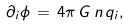Convert formula to latex. <formula><loc_0><loc_0><loc_500><loc_500>\partial _ { i } \phi \, = \, 4 \pi \, G \, n \, q _ { i } ,</formula> 